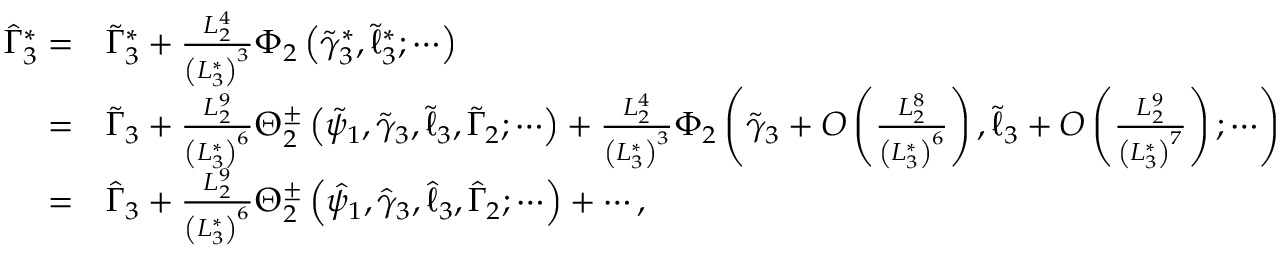<formula> <loc_0><loc_0><loc_500><loc_500>\begin{array} { r l } { \hat { \Gamma } _ { 3 } ^ { * } = } & { \tilde { \Gamma } _ { 3 } ^ { * } + \frac { L _ { 2 } ^ { 4 } } { \left ( L _ { 3 } ^ { * } \right ) ^ { 3 } } \Phi _ { 2 } \left ( \tilde { \gamma } _ { 3 } ^ { * } , \tilde { \ell } _ { 3 } ^ { * } ; \cdots \right ) } \\ { = } & { \tilde { \Gamma } _ { 3 } + \frac { L _ { 2 } ^ { 9 } } { \left ( L _ { 3 } ^ { * } \right ) ^ { 6 } } \Theta _ { 2 } ^ { \pm } \left ( \tilde { \psi } _ { 1 } , \tilde { \gamma } _ { 3 } , \tilde { \ell } _ { 3 } , \tilde { \Gamma } _ { 2 } ; \cdots \right ) + \frac { L _ { 2 } ^ { 4 } } { \left ( L _ { 3 } ^ { * } \right ) ^ { 3 } } \Phi _ { 2 } \left ( \tilde { \gamma } _ { 3 } + O \left ( \frac { L _ { 2 } ^ { 8 } } { \left ( L _ { 3 } ^ { * } \right ) ^ { 6 } } \right ) , \tilde { \ell } _ { 3 } + O \left ( \frac { L _ { 2 } ^ { 9 } } { \left ( L _ { 3 } ^ { * } \right ) ^ { 7 } } \right ) ; \cdots \right ) } \\ { = } & { \hat { \Gamma } _ { 3 } + \frac { L _ { 2 } ^ { 9 } } { \left ( L _ { 3 } ^ { * } \right ) ^ { 6 } } \Theta _ { 2 } ^ { \pm } \left ( \hat { \psi } _ { 1 } , \hat { \gamma } _ { 3 } , \hat { \ell } _ { 3 } , \hat { \Gamma } _ { 2 } ; \cdots \right ) + \cdots , } \end{array}</formula> 